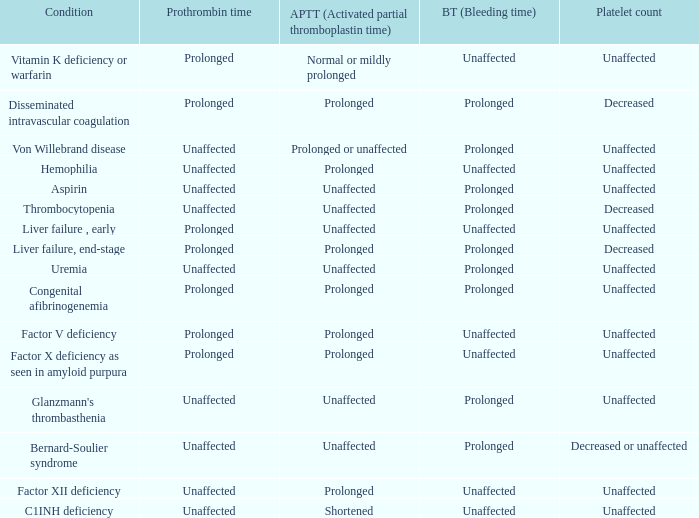Parse the full table. {'header': ['Condition', 'Prothrombin time', 'APTT (Activated partial thromboplastin time)', 'BT (Bleeding time)', 'Platelet count'], 'rows': [['Vitamin K deficiency or warfarin', 'Prolonged', 'Normal or mildly prolonged', 'Unaffected', 'Unaffected'], ['Disseminated intravascular coagulation', 'Prolonged', 'Prolonged', 'Prolonged', 'Decreased'], ['Von Willebrand disease', 'Unaffected', 'Prolonged or unaffected', 'Prolonged', 'Unaffected'], ['Hemophilia', 'Unaffected', 'Prolonged', 'Unaffected', 'Unaffected'], ['Aspirin', 'Unaffected', 'Unaffected', 'Prolonged', 'Unaffected'], ['Thrombocytopenia', 'Unaffected', 'Unaffected', 'Prolonged', 'Decreased'], ['Liver failure , early', 'Prolonged', 'Unaffected', 'Unaffected', 'Unaffected'], ['Liver failure, end-stage', 'Prolonged', 'Prolonged', 'Prolonged', 'Decreased'], ['Uremia', 'Unaffected', 'Unaffected', 'Prolonged', 'Unaffected'], ['Congenital afibrinogenemia', 'Prolonged', 'Prolonged', 'Prolonged', 'Unaffected'], ['Factor V deficiency', 'Prolonged', 'Prolonged', 'Unaffected', 'Unaffected'], ['Factor X deficiency as seen in amyloid purpura', 'Prolonged', 'Prolonged', 'Unaffected', 'Unaffected'], ["Glanzmann's thrombasthenia", 'Unaffected', 'Unaffected', 'Prolonged', 'Unaffected'], ['Bernard-Soulier syndrome', 'Unaffected', 'Unaffected', 'Prolonged', 'Decreased or unaffected'], ['Factor XII deficiency', 'Unaffected', 'Prolonged', 'Unaffected', 'Unaffected'], ['C1INH deficiency', 'Unaffected', 'Shortened', 'Unaffected', 'Unaffected']]} Which Condition has an unaffected Prothrombin time and a Bleeding time, and a Partial thromboplastin time of prolonged? Hemophilia, Factor XII deficiency. 